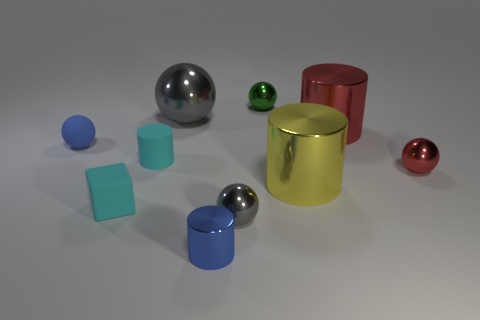Can you tell me something about the lighting in this scene? Certainly! The lighting in the scene comes from above, casting soft shadows directly under the objects. The shadows are minimal and diffused, suggesting the light source may be large or there are multiple sources creating an ambient effect. Moreover, the objects display highlights and reflective qualities, indicating the light is fairly bright.  What could this arrangement of objects represent? This assortment of geometric shapes might represent the concept of variety or diversity, expressing how various elements can coexist harmoniously. It may also be an abstract representation of the components needed for a particular system or a stylized portrayal of shapes that could educate viewers about geometry and spatial relations. 